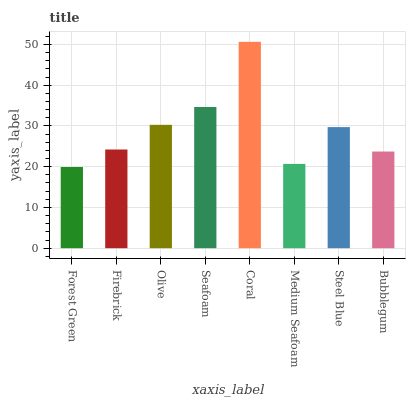Is Firebrick the minimum?
Answer yes or no. No. Is Firebrick the maximum?
Answer yes or no. No. Is Firebrick greater than Forest Green?
Answer yes or no. Yes. Is Forest Green less than Firebrick?
Answer yes or no. Yes. Is Forest Green greater than Firebrick?
Answer yes or no. No. Is Firebrick less than Forest Green?
Answer yes or no. No. Is Steel Blue the high median?
Answer yes or no. Yes. Is Firebrick the low median?
Answer yes or no. Yes. Is Forest Green the high median?
Answer yes or no. No. Is Coral the low median?
Answer yes or no. No. 